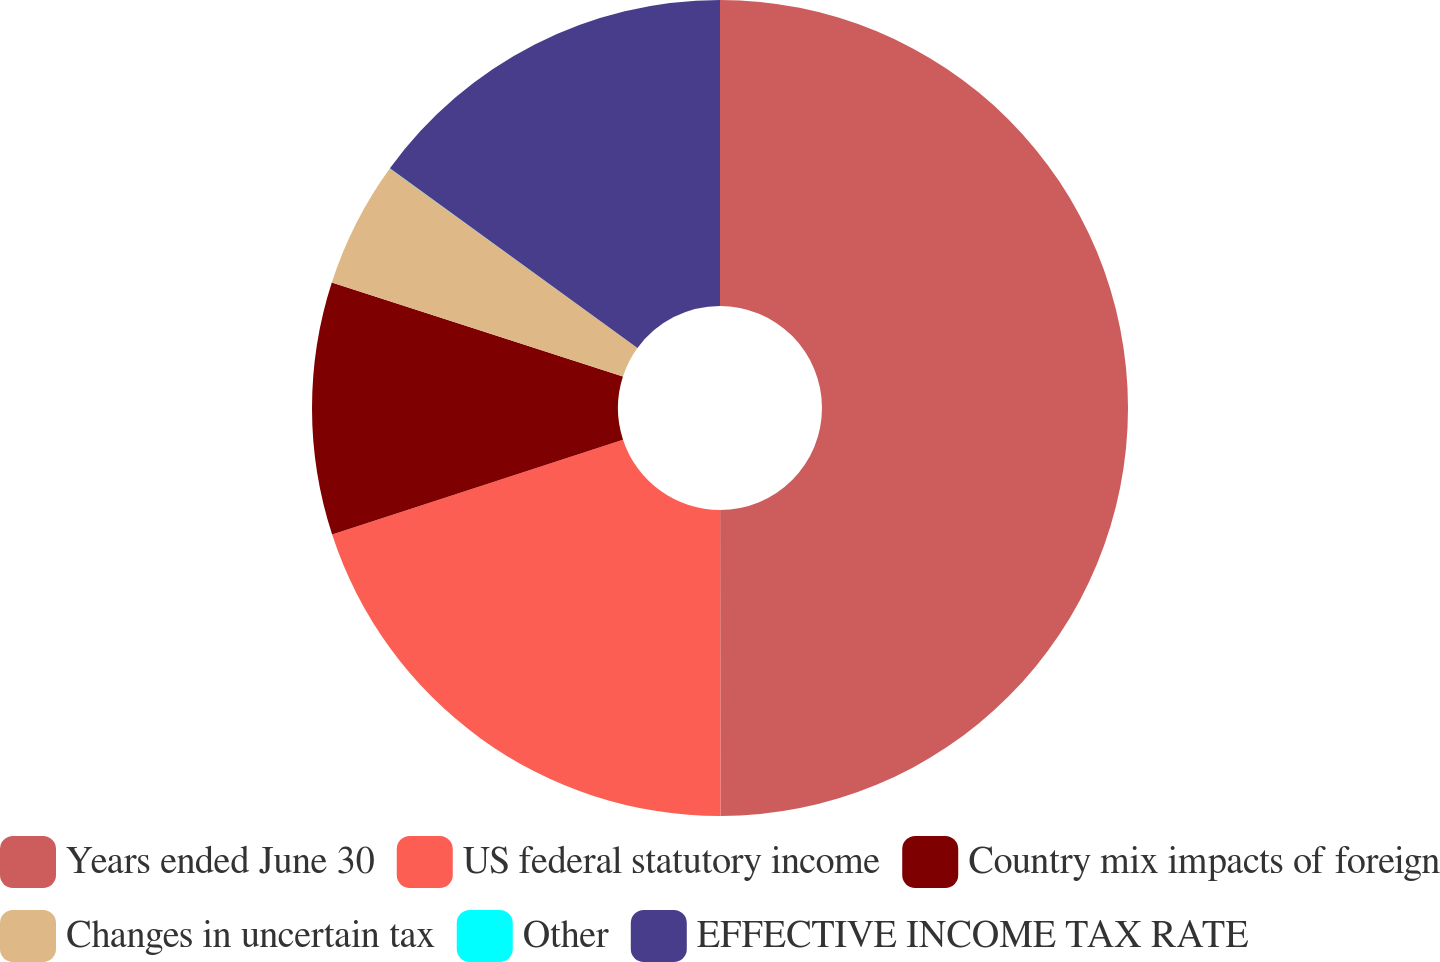Convert chart to OTSL. <chart><loc_0><loc_0><loc_500><loc_500><pie_chart><fcel>Years ended June 30<fcel>US federal statutory income<fcel>Country mix impacts of foreign<fcel>Changes in uncertain tax<fcel>Other<fcel>EFFECTIVE INCOME TAX RATE<nl><fcel>49.98%<fcel>20.0%<fcel>10.0%<fcel>5.01%<fcel>0.01%<fcel>15.0%<nl></chart> 